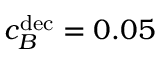Convert formula to latex. <formula><loc_0><loc_0><loc_500><loc_500>c _ { B } ^ { d e c } = 0 . 0 5</formula> 